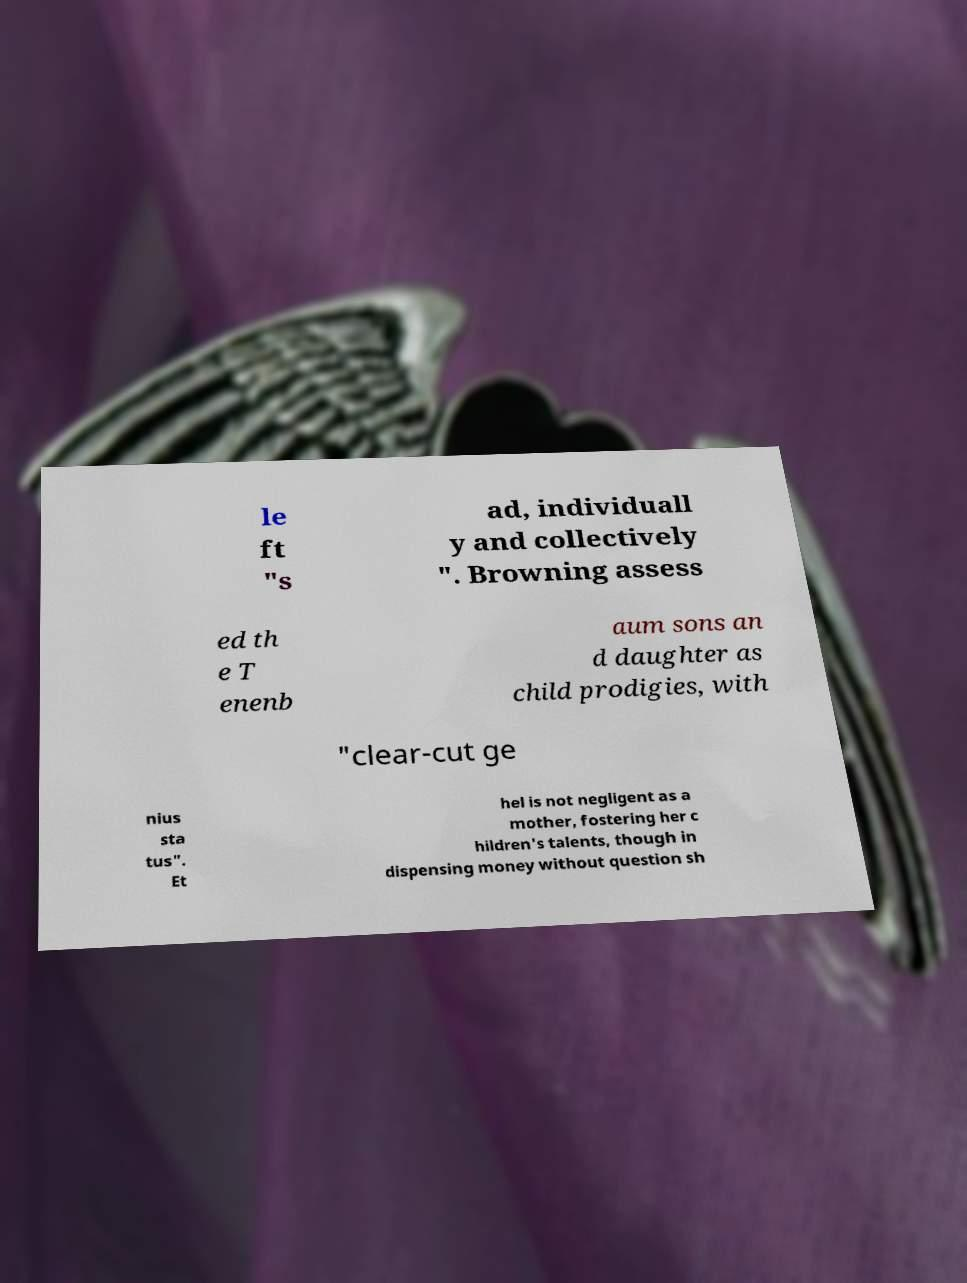Can you read and provide the text displayed in the image?This photo seems to have some interesting text. Can you extract and type it out for me? le ft "s ad, individuall y and collectively ". Browning assess ed th e T enenb aum sons an d daughter as child prodigies, with "clear-cut ge nius sta tus". Et hel is not negligent as a mother, fostering her c hildren's talents, though in dispensing money without question sh 